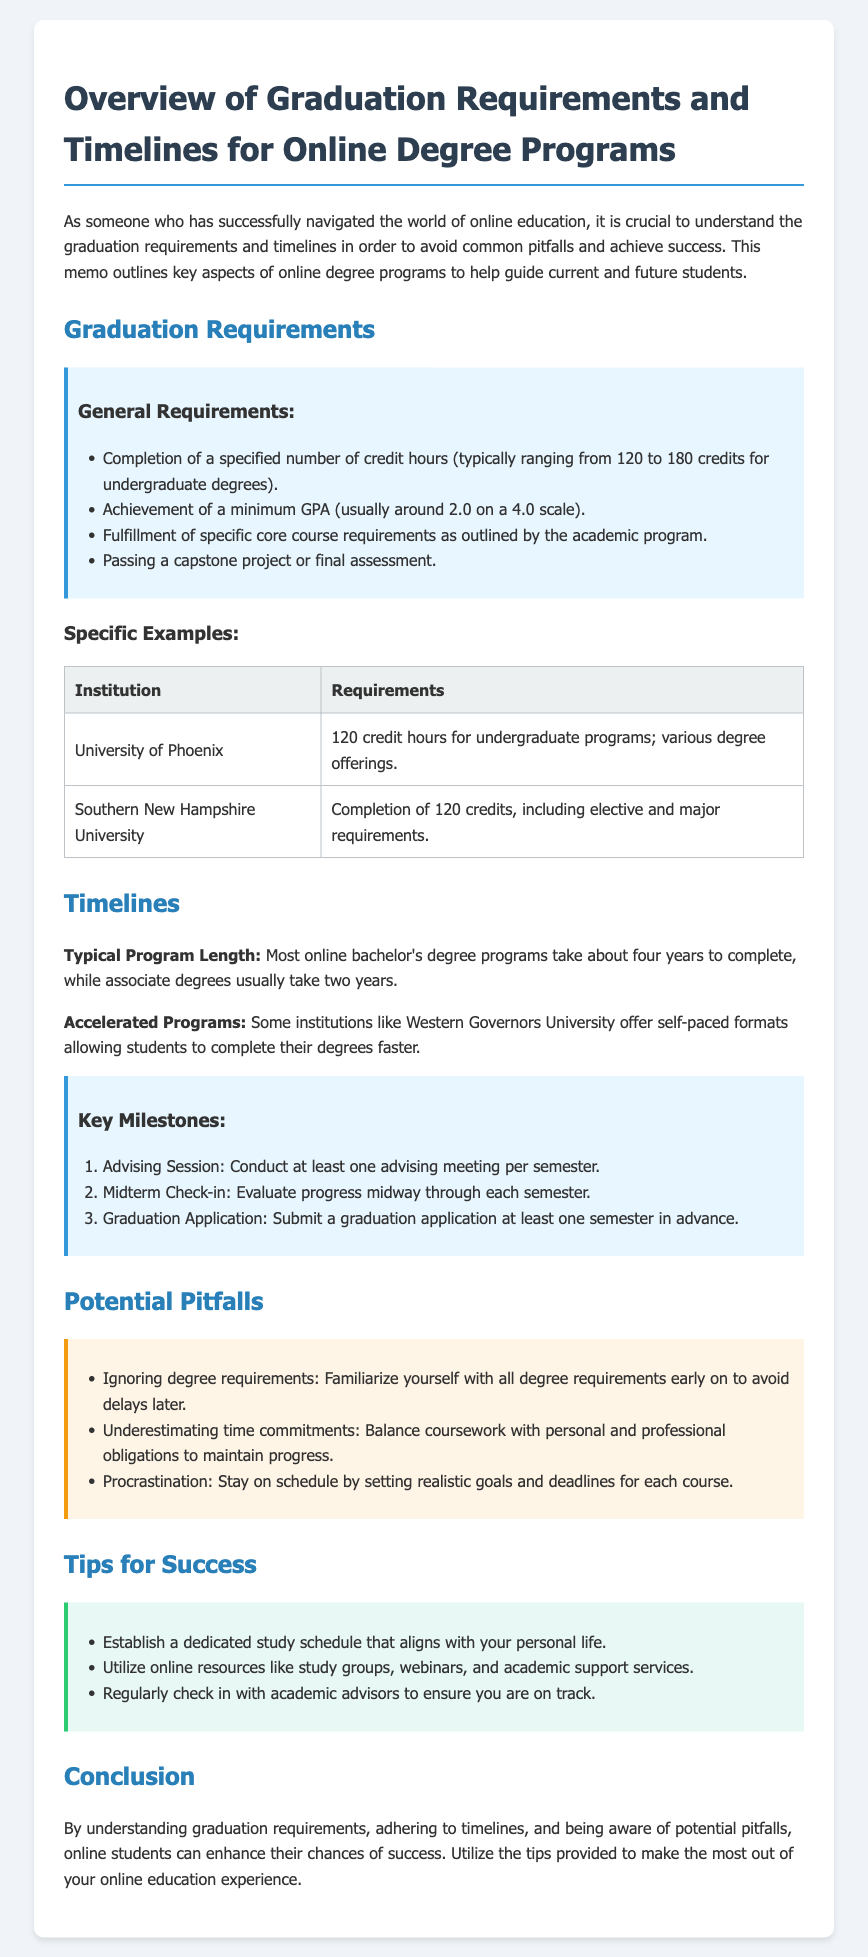What is the typical number of credit hours required for undergraduate degrees? The document states that undergraduate degrees typically require completion of 120 to 180 credits.
Answer: 120 to 180 credits What is the minimum GPA generally required? The memo mentions that the minimum GPA usually required is around 2.0 on a 4.0 scale.
Answer: 2.0 Which institution offers a self-paced degree format? The document specifies that Western Governors University offers self-paced formats for degree completion.
Answer: Western Governors University What should students do at least one semester in advance of graduation? The document states that students should submit a graduation application at least one semester in advance.
Answer: Submit a graduation application What are two potential pitfalls mentioned? The document discusses several pitfalls, including ignoring degree requirements and underestimating time commitments.
Answer: Ignoring degree requirements, underestimating time commitments What is a recommended strategy for successful studying? The memo advises establishing a dedicated study schedule that aligns with personal life.
Answer: Establish a dedicated study schedule How often should students conduct advising sessions? According to the document, students should conduct at least one advising meeting per semester.
Answer: At least once per semester What is the typical program length for most online bachelor's degrees? The memo indicates that most online bachelor's degree programs take about four years to complete.
Answer: About four years What is one tip for utilizing online education resources effectively? The memo suggests utilizing online resources like study groups, webinars, and academic support services.
Answer: Utilize online resources like study groups 